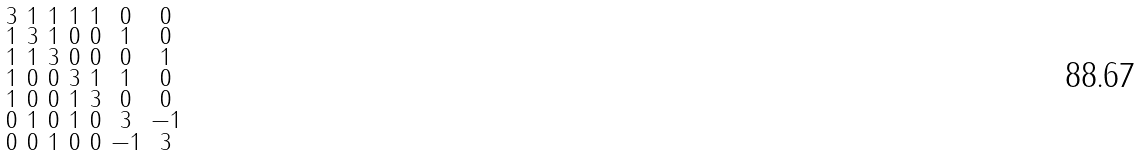<formula> <loc_0><loc_0><loc_500><loc_500>\begin{smallmatrix} 3 & 1 & 1 & 1 & 1 & 0 & 0 \\ 1 & 3 & 1 & 0 & 0 & 1 & 0 \\ 1 & 1 & 3 & 0 & 0 & 0 & 1 \\ 1 & 0 & 0 & 3 & 1 & 1 & 0 \\ 1 & 0 & 0 & 1 & 3 & 0 & 0 \\ 0 & 1 & 0 & 1 & 0 & 3 & - 1 \\ 0 & 0 & 1 & 0 & 0 & - 1 & 3 \end{smallmatrix}</formula> 